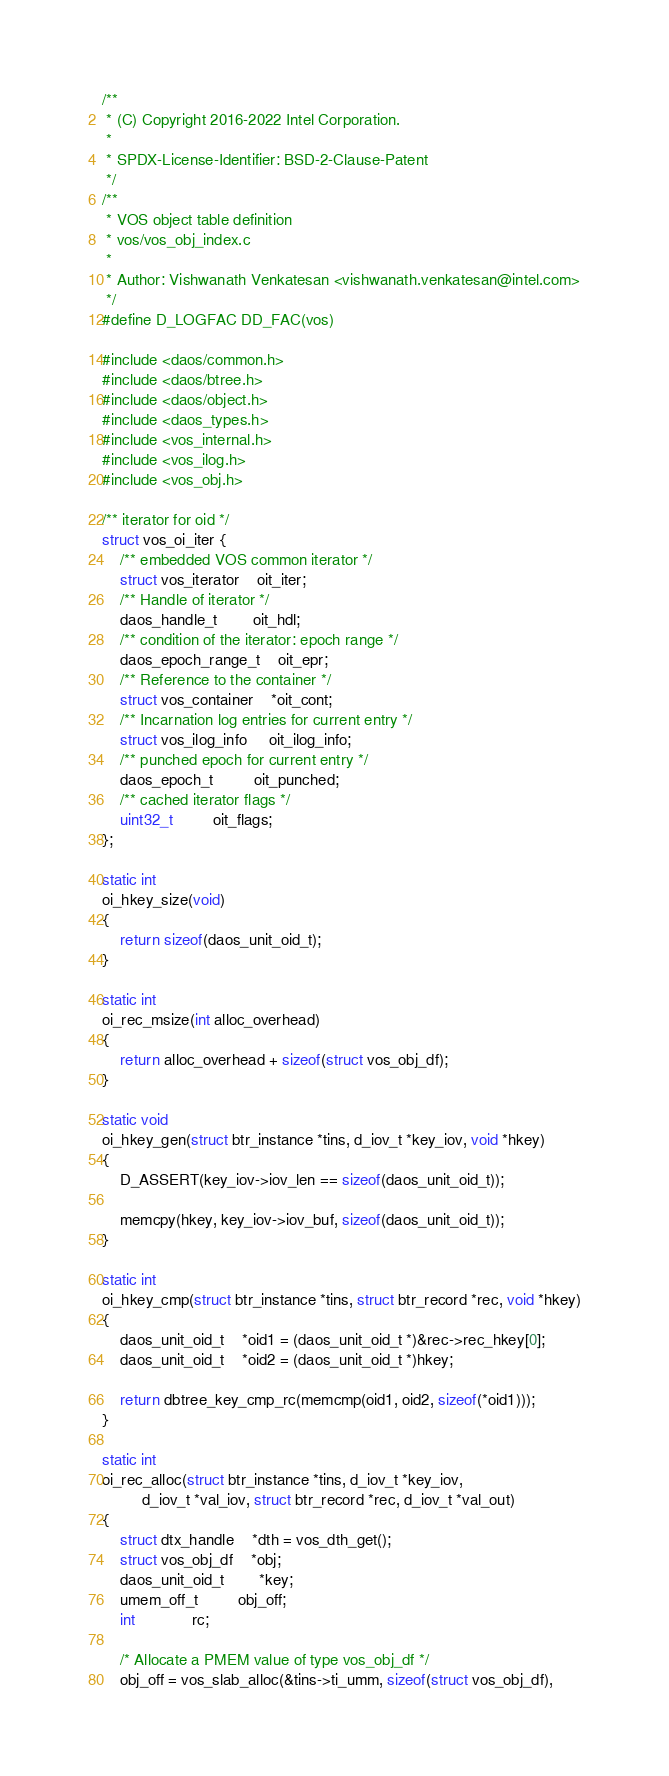<code> <loc_0><loc_0><loc_500><loc_500><_C_>/**
 * (C) Copyright 2016-2022 Intel Corporation.
 *
 * SPDX-License-Identifier: BSD-2-Clause-Patent
 */
/**
 * VOS object table definition
 * vos/vos_obj_index.c
 *
 * Author: Vishwanath Venkatesan <vishwanath.venkatesan@intel.com>
 */
#define D_LOGFAC	DD_FAC(vos)

#include <daos/common.h>
#include <daos/btree.h>
#include <daos/object.h>
#include <daos_types.h>
#include <vos_internal.h>
#include <vos_ilog.h>
#include <vos_obj.h>

/** iterator for oid */
struct vos_oi_iter {
	/** embedded VOS common iterator */
	struct vos_iterator	oit_iter;
	/** Handle of iterator */
	daos_handle_t		oit_hdl;
	/** condition of the iterator: epoch range */
	daos_epoch_range_t	oit_epr;
	/** Reference to the container */
	struct vos_container	*oit_cont;
	/** Incarnation log entries for current entry */
	struct vos_ilog_info	 oit_ilog_info;
	/** punched epoch for current entry */
	daos_epoch_t		 oit_punched;
	/** cached iterator flags */
	uint32_t		 oit_flags;
};

static int
oi_hkey_size(void)
{
	return sizeof(daos_unit_oid_t);
}

static int
oi_rec_msize(int alloc_overhead)
{
	return alloc_overhead + sizeof(struct vos_obj_df);
}

static void
oi_hkey_gen(struct btr_instance *tins, d_iov_t *key_iov, void *hkey)
{
	D_ASSERT(key_iov->iov_len == sizeof(daos_unit_oid_t));

	memcpy(hkey, key_iov->iov_buf, sizeof(daos_unit_oid_t));
}

static int
oi_hkey_cmp(struct btr_instance *tins, struct btr_record *rec, void *hkey)
{
	daos_unit_oid_t	*oid1 = (daos_unit_oid_t *)&rec->rec_hkey[0];
	daos_unit_oid_t	*oid2 = (daos_unit_oid_t *)hkey;

	return dbtree_key_cmp_rc(memcmp(oid1, oid2, sizeof(*oid1)));
}

static int
oi_rec_alloc(struct btr_instance *tins, d_iov_t *key_iov,
	     d_iov_t *val_iov, struct btr_record *rec, d_iov_t *val_out)
{
	struct dtx_handle	*dth = vos_dth_get();
	struct vos_obj_df	*obj;
	daos_unit_oid_t		*key;
	umem_off_t		 obj_off;
	int			 rc;

	/* Allocate a PMEM value of type vos_obj_df */
	obj_off = vos_slab_alloc(&tins->ti_umm, sizeof(struct vos_obj_df),</code> 